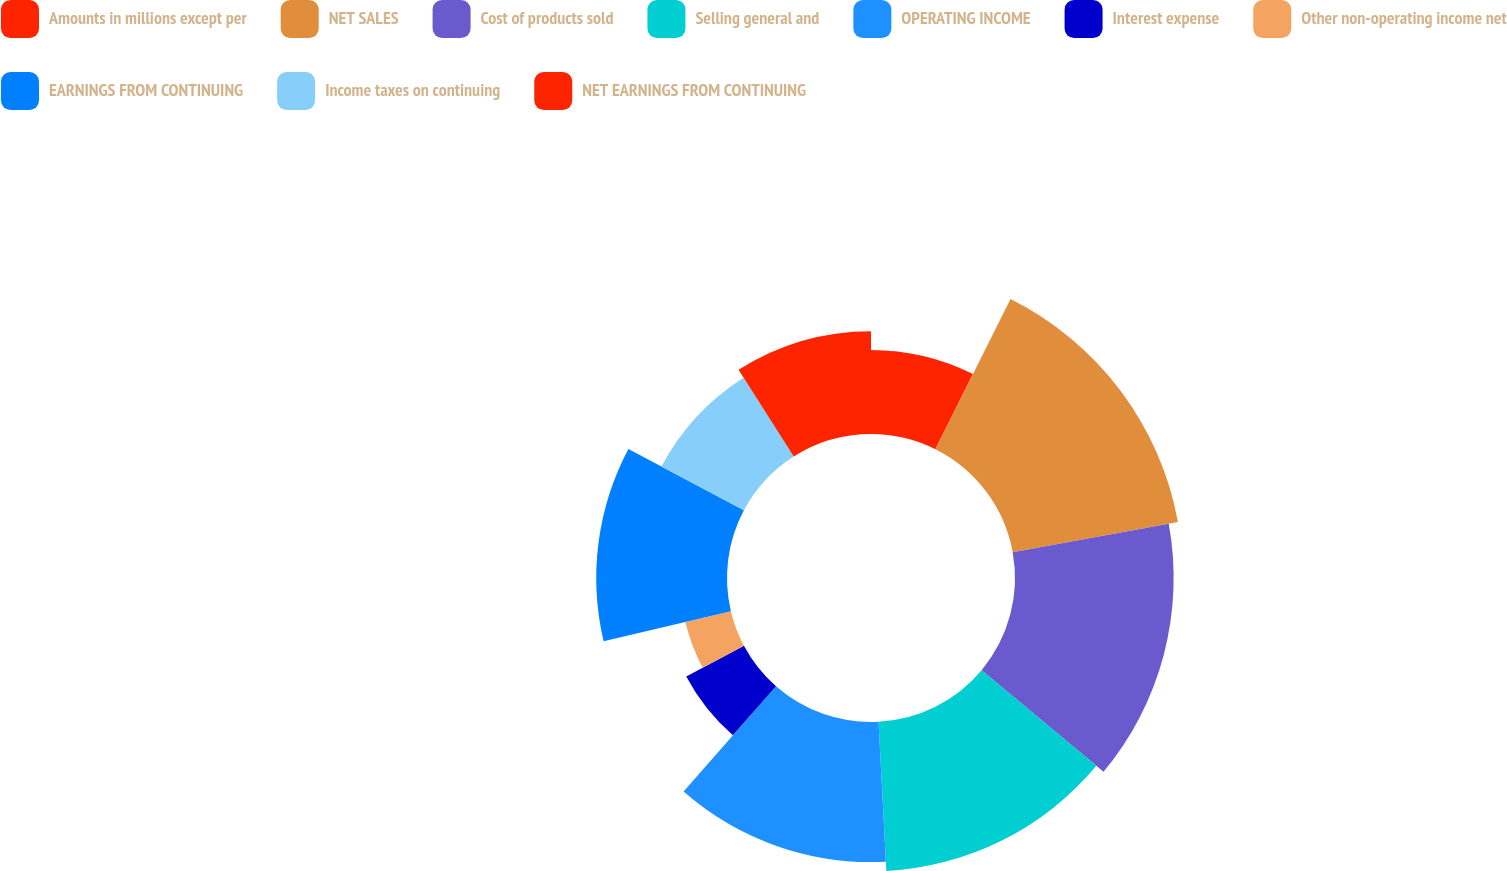<chart> <loc_0><loc_0><loc_500><loc_500><pie_chart><fcel>Amounts in millions except per<fcel>NET SALES<fcel>Cost of products sold<fcel>Selling general and<fcel>OPERATING INCOME<fcel>Interest expense<fcel>Other non-operating income net<fcel>EARNINGS FROM CONTINUING<fcel>Income taxes on continuing<fcel>NET EARNINGS FROM CONTINUING<nl><fcel>7.38%<fcel>14.75%<fcel>13.93%<fcel>13.11%<fcel>12.3%<fcel>5.74%<fcel>4.1%<fcel>11.48%<fcel>8.2%<fcel>9.02%<nl></chart> 